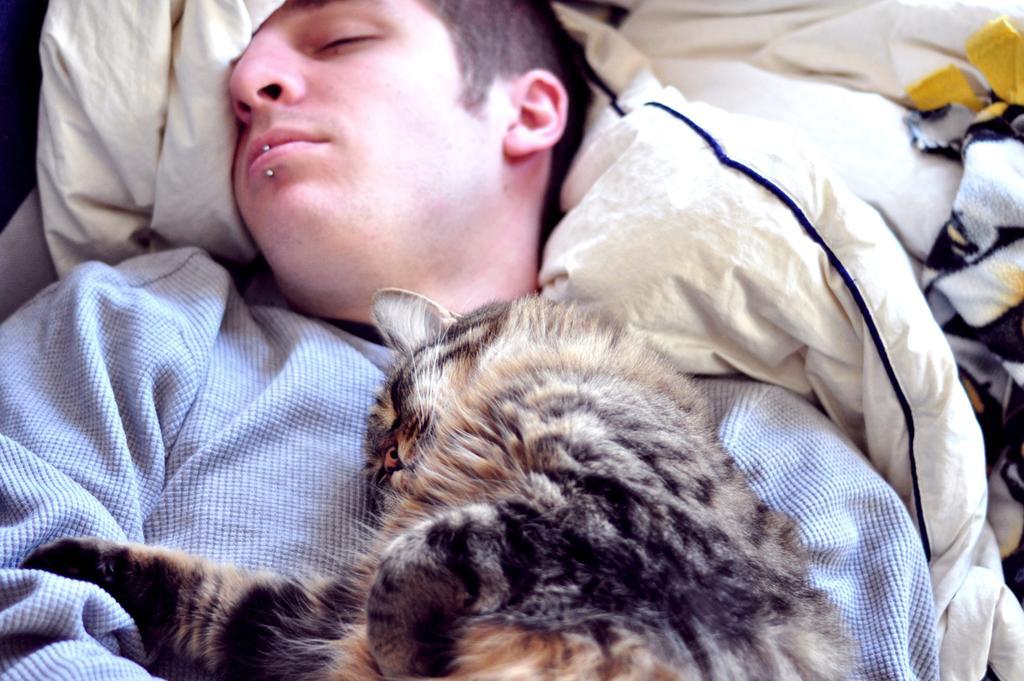Could you give a brief overview of what you see in this image? In this image I can see a man and a cat on his chest. I can also see few clothes over here. 